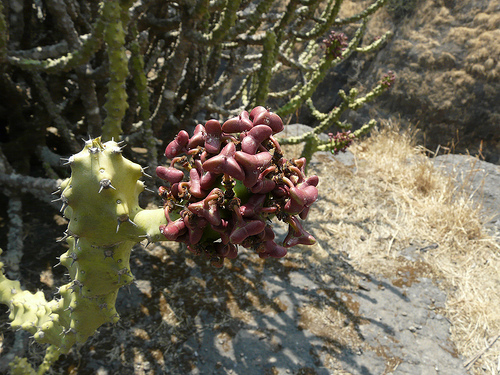<image>
Is there a flowers to the left of the cactus? Yes. From this viewpoint, the flowers is positioned to the left side relative to the cactus. 